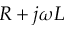<formula> <loc_0><loc_0><loc_500><loc_500>R + j \omega L</formula> 